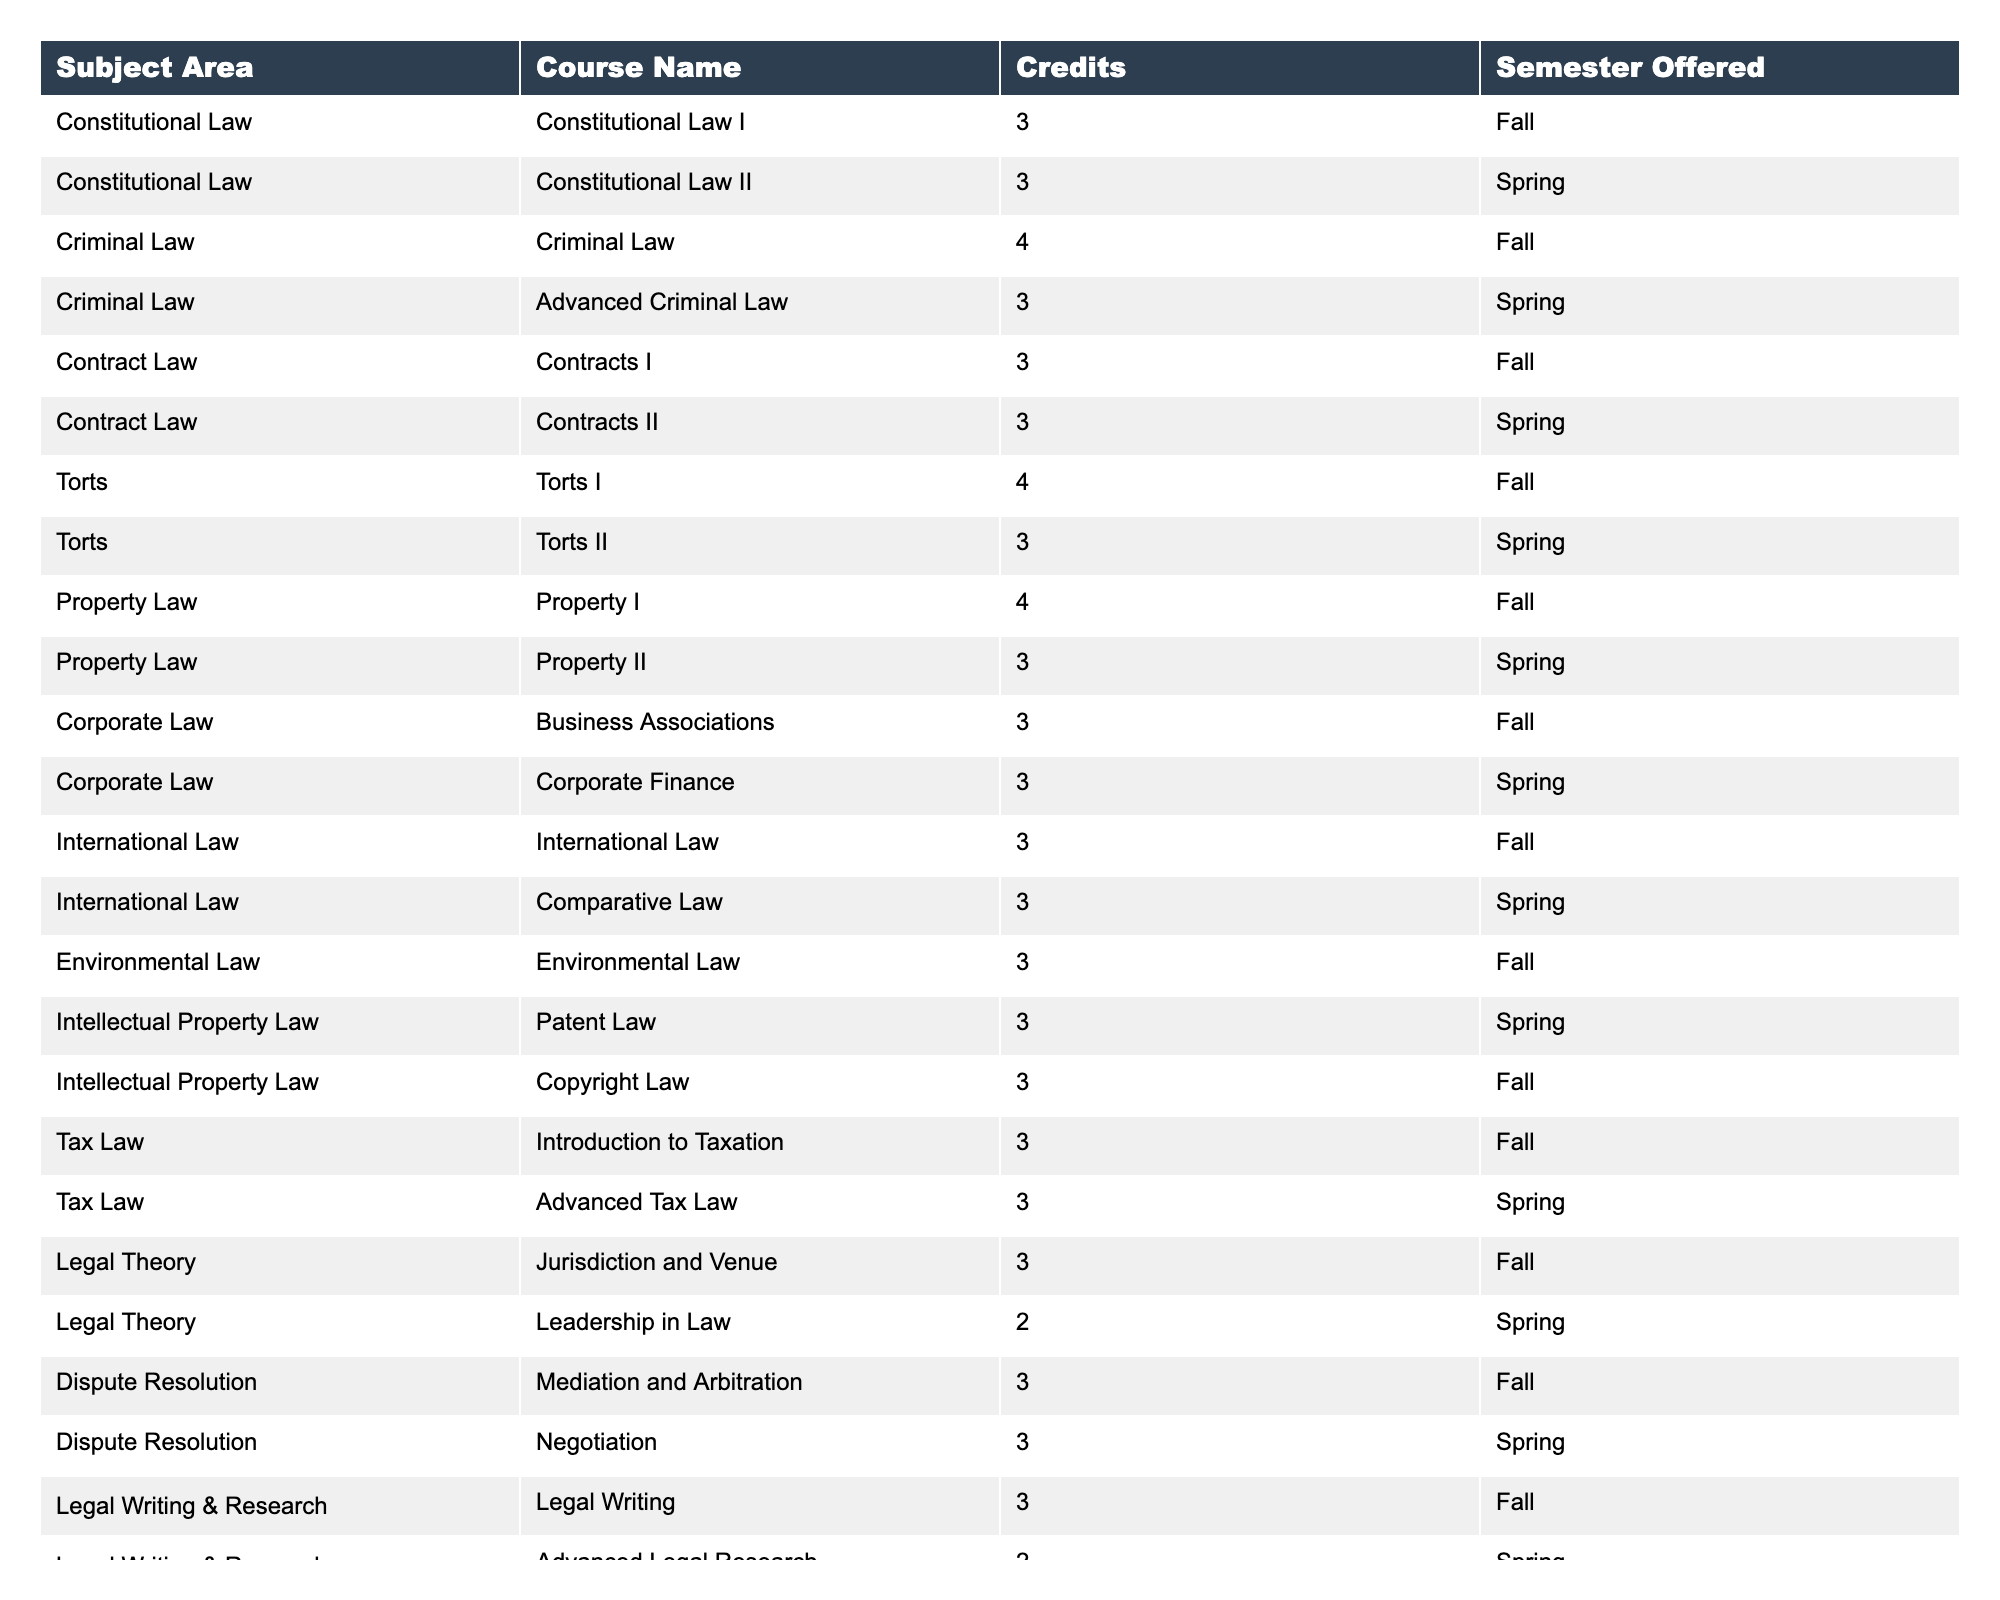What is the total number of courses offered in Property Law? There are two courses listed under Property Law: Property I and Property II. Therefore, the total number of courses in this subject area is 2.
Answer: 2 Which course has the highest number of credits, and how many are they? The course with the highest number of credits is Criminal Law, which has 4 credits.
Answer: Criminal Law, 4 Are there any courses in Legal Writing & Research offered in the Spring semester? There is one course listed in Legal Writing & Research for the Spring semester, which is Advanced Legal Research.
Answer: Yes What is the average number of credits for courses offered in Criminal Law? There are two Criminal Law courses: Criminal Law (4 credits) and Advanced Criminal Law (3 credits). The average is computed as (4 + 3) / 2 = 3.5.
Answer: 3.5 How many subject areas have courses offered in both Fall and Spring semesters? The subject areas with courses in both semesters are Constitutional Law, Criminal Law, Contract Law, Torts, Property Law, Corporate Law, International Law, Intellectual Property Law, Tax Law, Legal Theory, Dispute Resolution, and Legal Writing & Research. This gives a total of 11 subject areas.
Answer: 11 Is there a course in Environmental Law offered in the Spring semester? Environmental Law is only listed as being offered in the Fall semester, hence no course is available in the Spring.
Answer: No Which subject area has the least number of courses, and how many courses does it offer? The subject area with the least number of courses is Legal Theory with 2 courses (Jurisdiction and Venue, Leadership in Law).
Answer: Legal Theory, 2 What is the total number of credits for all courses offered in International Law? The courses in International Law are International Law and Comparative Law, both offering 3 credits each. Therefore, the total number of credits is 3 + 3 = 6.
Answer: 6 How many courses are offered in Torts and what is their credit range? There are two courses offered in Torts: Torts I (4 credits) and Torts II (3 credits). The credit range is from 3 to 4 credits.
Answer: 2 courses, 3 to 4 credits What percentage of courses offered have a credit value of 3? There are 14 courses with a credit value of 3 out of a total of 26 courses offered. The percentage is (14 / 26) * 100 ≈ 53.85%.
Answer: ~53.85% 